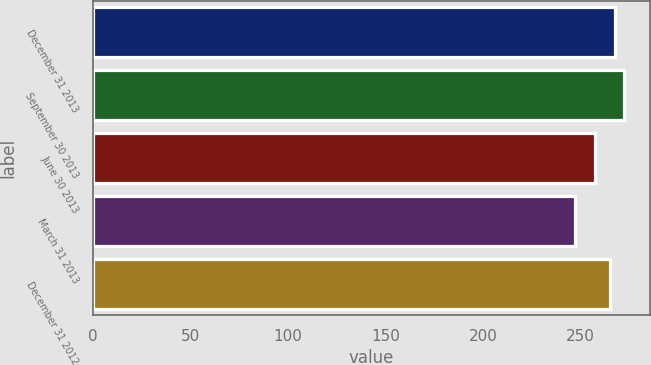<chart> <loc_0><loc_0><loc_500><loc_500><bar_chart><fcel>December 31 2013<fcel>September 30 2013<fcel>June 30 2013<fcel>March 31 2013<fcel>December 31 2012<nl><fcel>267.67<fcel>272<fcel>257.6<fcel>247.3<fcel>265.2<nl></chart> 